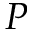Convert formula to latex. <formula><loc_0><loc_0><loc_500><loc_500>P</formula> 